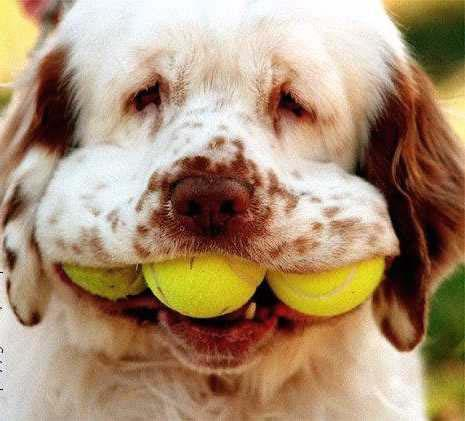What material is used to make the balls in the dogs mouth?

Choices:
A) leather
B) plastic
C) horsehair
D) rubber rubber 